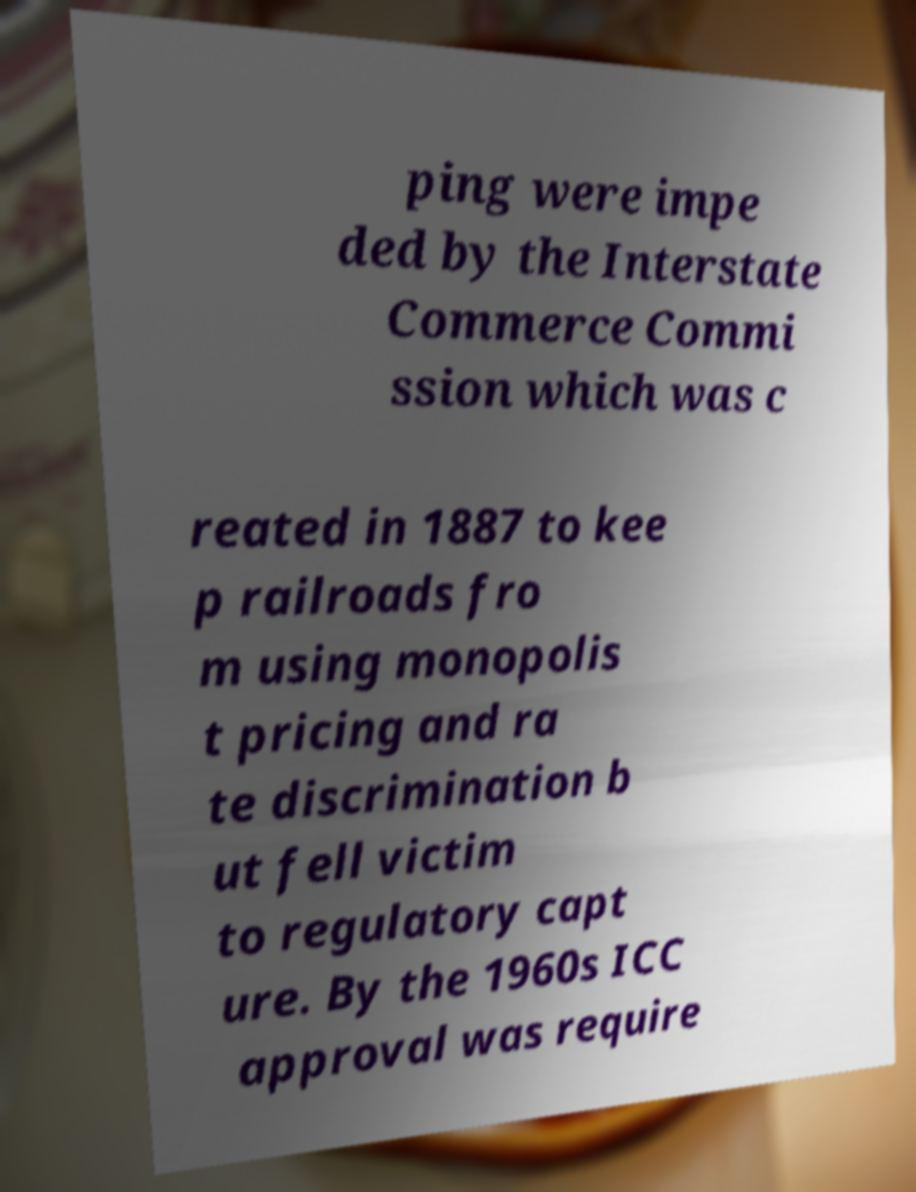There's text embedded in this image that I need extracted. Can you transcribe it verbatim? ping were impe ded by the Interstate Commerce Commi ssion which was c reated in 1887 to kee p railroads fro m using monopolis t pricing and ra te discrimination b ut fell victim to regulatory capt ure. By the 1960s ICC approval was require 